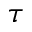Convert formula to latex. <formula><loc_0><loc_0><loc_500><loc_500>\tau</formula> 